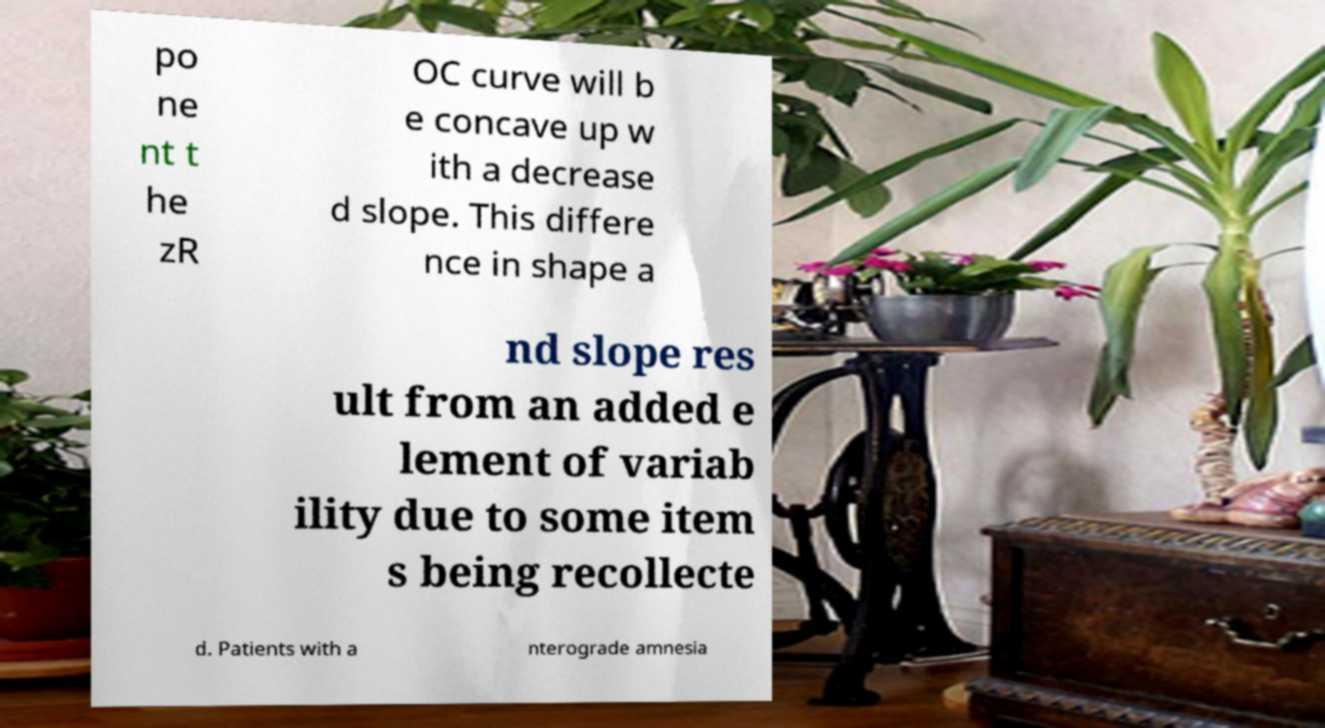Could you assist in decoding the text presented in this image and type it out clearly? po ne nt t he zR OC curve will b e concave up w ith a decrease d slope. This differe nce in shape a nd slope res ult from an added e lement of variab ility due to some item s being recollecte d. Patients with a nterograde amnesia 